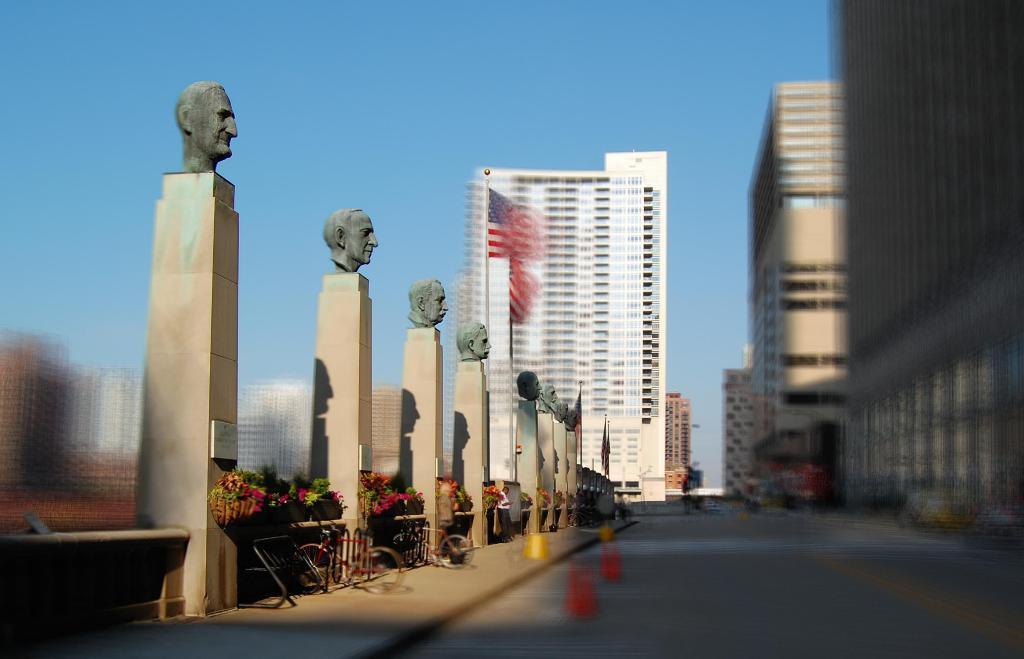Please provide a concise description of this image. In this image I can see few plants, I can see few flowers in multi color and pillars, on the pillars I can see few statues. Background I can see a flag and building in white color, sky in blue color. 